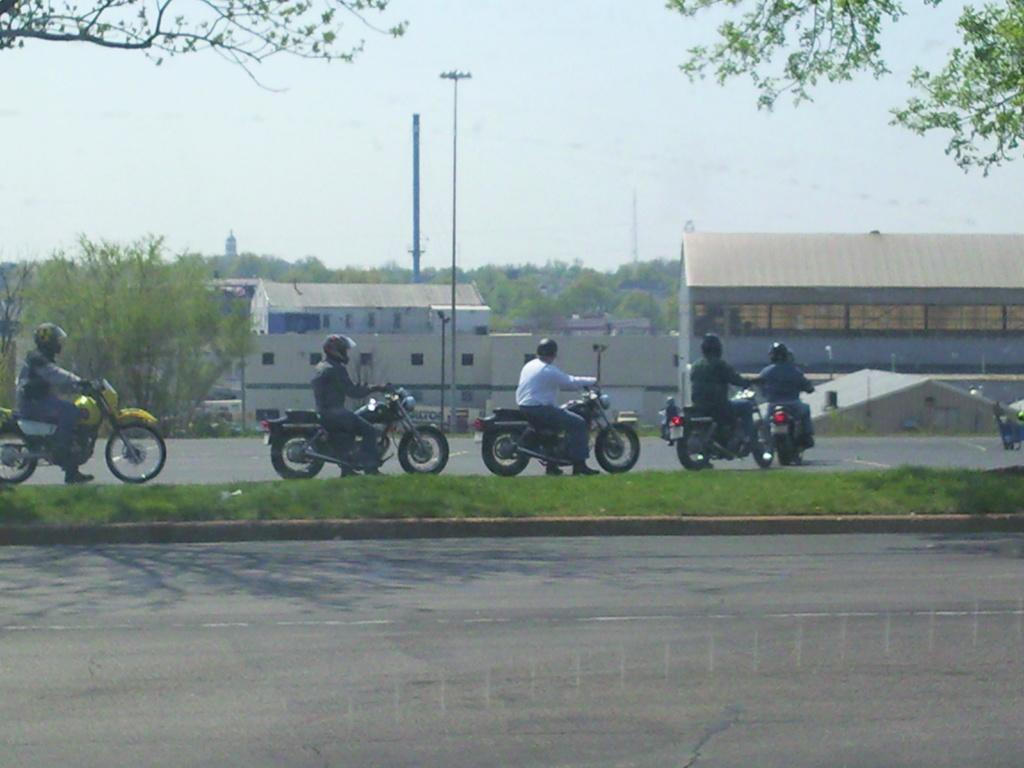What are the people in the image doing? The people in the image are riding bikes. What can be seen in the distance behind the people? There are buildings and trees in the background of the image. What type of pickle is being used to lubricate the bike chains in the image? There is no pickle present in the image, and bike chains are not lubricated with pickles. 